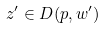Convert formula to latex. <formula><loc_0><loc_0><loc_500><loc_500>z ^ { \prime } \in D ( p , w ^ { \prime } )</formula> 